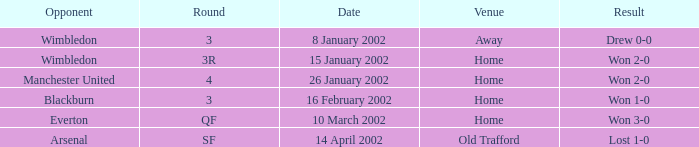What is the Venue with a Date with 14 april 2002? Old Trafford. 